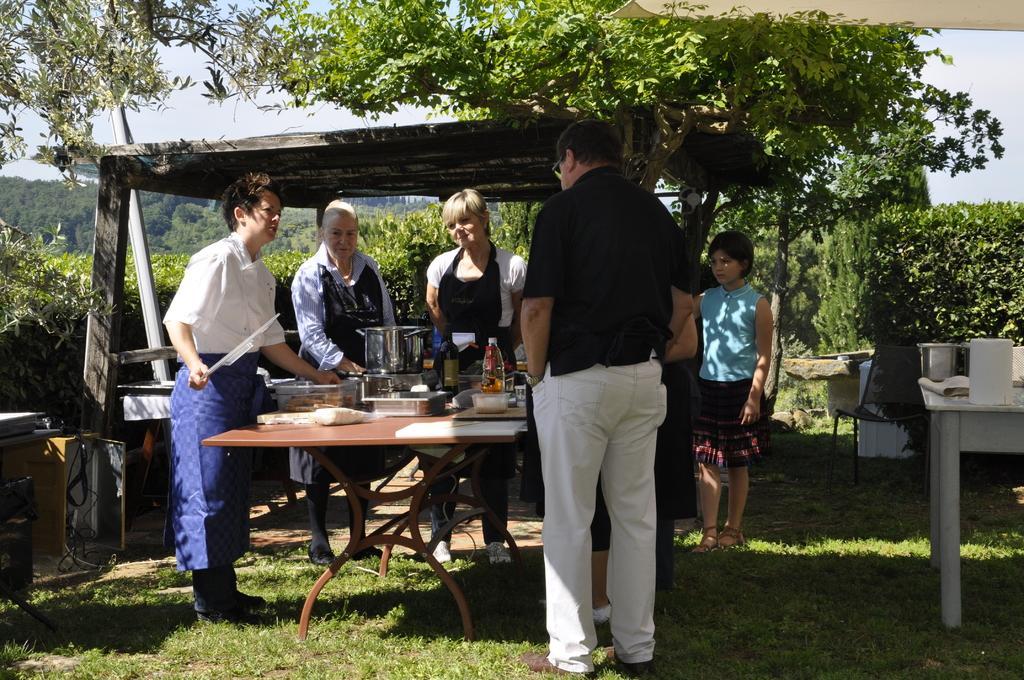In one or two sentences, can you explain what this image depicts? In this image few people are standing around a table. On the table there are vessels, bottle, box, food. There is a table on the right. In the background there are trees. 